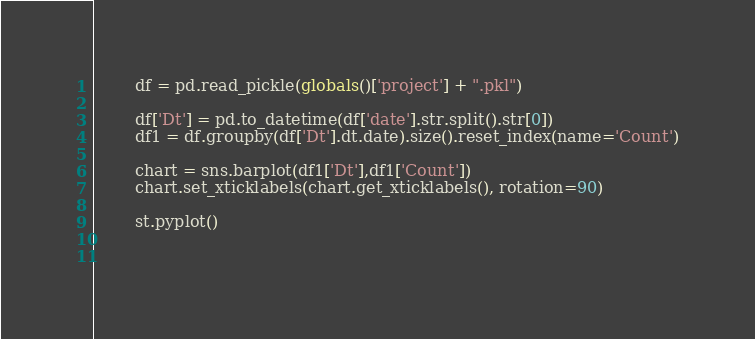<code> <loc_0><loc_0><loc_500><loc_500><_Python_>        df = pd.read_pickle(globals()['project'] + ".pkl")

        df['Dt'] = pd.to_datetime(df['date'].str.split().str[0])
        df1 = df.groupby(df['Dt'].dt.date).size().reset_index(name='Count')

        chart = sns.barplot(df1['Dt'],df1['Count'])
        chart.set_xticklabels(chart.get_xticklabels(), rotation=90)

        st.pyplot()
        
    </code> 